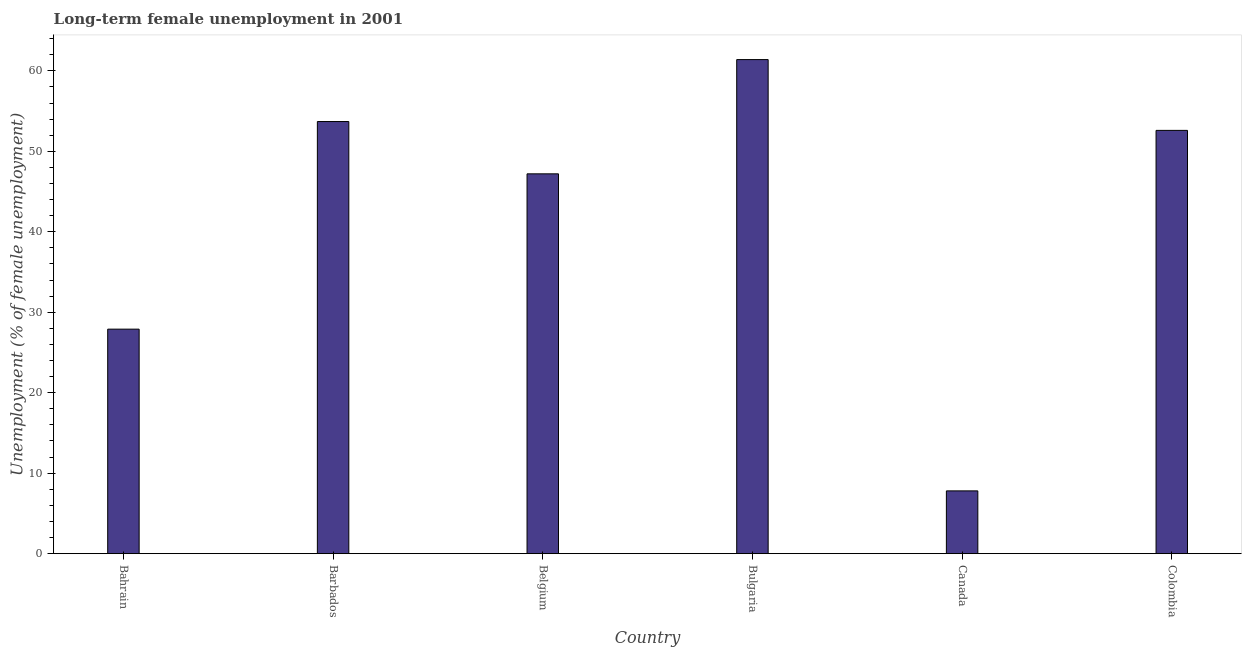What is the title of the graph?
Offer a terse response. Long-term female unemployment in 2001. What is the label or title of the X-axis?
Offer a terse response. Country. What is the label or title of the Y-axis?
Provide a short and direct response. Unemployment (% of female unemployment). What is the long-term female unemployment in Colombia?
Your response must be concise. 52.6. Across all countries, what is the maximum long-term female unemployment?
Keep it short and to the point. 61.4. Across all countries, what is the minimum long-term female unemployment?
Provide a short and direct response. 7.8. In which country was the long-term female unemployment minimum?
Make the answer very short. Canada. What is the sum of the long-term female unemployment?
Provide a short and direct response. 250.6. What is the difference between the long-term female unemployment in Bulgaria and Canada?
Offer a very short reply. 53.6. What is the average long-term female unemployment per country?
Give a very brief answer. 41.77. What is the median long-term female unemployment?
Make the answer very short. 49.9. In how many countries, is the long-term female unemployment greater than 16 %?
Make the answer very short. 5. What is the ratio of the long-term female unemployment in Bulgaria to that in Canada?
Ensure brevity in your answer.  7.87. Is the long-term female unemployment in Bulgaria less than that in Canada?
Ensure brevity in your answer.  No. Is the sum of the long-term female unemployment in Canada and Colombia greater than the maximum long-term female unemployment across all countries?
Provide a short and direct response. No. What is the difference between the highest and the lowest long-term female unemployment?
Provide a succinct answer. 53.6. How many countries are there in the graph?
Offer a very short reply. 6. What is the Unemployment (% of female unemployment) of Bahrain?
Offer a terse response. 27.9. What is the Unemployment (% of female unemployment) of Barbados?
Give a very brief answer. 53.7. What is the Unemployment (% of female unemployment) of Belgium?
Your response must be concise. 47.2. What is the Unemployment (% of female unemployment) in Bulgaria?
Your answer should be very brief. 61.4. What is the Unemployment (% of female unemployment) of Canada?
Provide a succinct answer. 7.8. What is the Unemployment (% of female unemployment) of Colombia?
Give a very brief answer. 52.6. What is the difference between the Unemployment (% of female unemployment) in Bahrain and Barbados?
Ensure brevity in your answer.  -25.8. What is the difference between the Unemployment (% of female unemployment) in Bahrain and Belgium?
Provide a succinct answer. -19.3. What is the difference between the Unemployment (% of female unemployment) in Bahrain and Bulgaria?
Make the answer very short. -33.5. What is the difference between the Unemployment (% of female unemployment) in Bahrain and Canada?
Make the answer very short. 20.1. What is the difference between the Unemployment (% of female unemployment) in Bahrain and Colombia?
Make the answer very short. -24.7. What is the difference between the Unemployment (% of female unemployment) in Barbados and Bulgaria?
Make the answer very short. -7.7. What is the difference between the Unemployment (% of female unemployment) in Barbados and Canada?
Provide a succinct answer. 45.9. What is the difference between the Unemployment (% of female unemployment) in Belgium and Canada?
Offer a very short reply. 39.4. What is the difference between the Unemployment (% of female unemployment) in Belgium and Colombia?
Make the answer very short. -5.4. What is the difference between the Unemployment (% of female unemployment) in Bulgaria and Canada?
Offer a terse response. 53.6. What is the difference between the Unemployment (% of female unemployment) in Bulgaria and Colombia?
Keep it short and to the point. 8.8. What is the difference between the Unemployment (% of female unemployment) in Canada and Colombia?
Offer a terse response. -44.8. What is the ratio of the Unemployment (% of female unemployment) in Bahrain to that in Barbados?
Make the answer very short. 0.52. What is the ratio of the Unemployment (% of female unemployment) in Bahrain to that in Belgium?
Make the answer very short. 0.59. What is the ratio of the Unemployment (% of female unemployment) in Bahrain to that in Bulgaria?
Your answer should be compact. 0.45. What is the ratio of the Unemployment (% of female unemployment) in Bahrain to that in Canada?
Provide a short and direct response. 3.58. What is the ratio of the Unemployment (% of female unemployment) in Bahrain to that in Colombia?
Give a very brief answer. 0.53. What is the ratio of the Unemployment (% of female unemployment) in Barbados to that in Belgium?
Your answer should be compact. 1.14. What is the ratio of the Unemployment (% of female unemployment) in Barbados to that in Bulgaria?
Provide a succinct answer. 0.88. What is the ratio of the Unemployment (% of female unemployment) in Barbados to that in Canada?
Provide a succinct answer. 6.88. What is the ratio of the Unemployment (% of female unemployment) in Belgium to that in Bulgaria?
Offer a terse response. 0.77. What is the ratio of the Unemployment (% of female unemployment) in Belgium to that in Canada?
Offer a terse response. 6.05. What is the ratio of the Unemployment (% of female unemployment) in Belgium to that in Colombia?
Keep it short and to the point. 0.9. What is the ratio of the Unemployment (% of female unemployment) in Bulgaria to that in Canada?
Offer a terse response. 7.87. What is the ratio of the Unemployment (% of female unemployment) in Bulgaria to that in Colombia?
Provide a succinct answer. 1.17. What is the ratio of the Unemployment (% of female unemployment) in Canada to that in Colombia?
Your response must be concise. 0.15. 